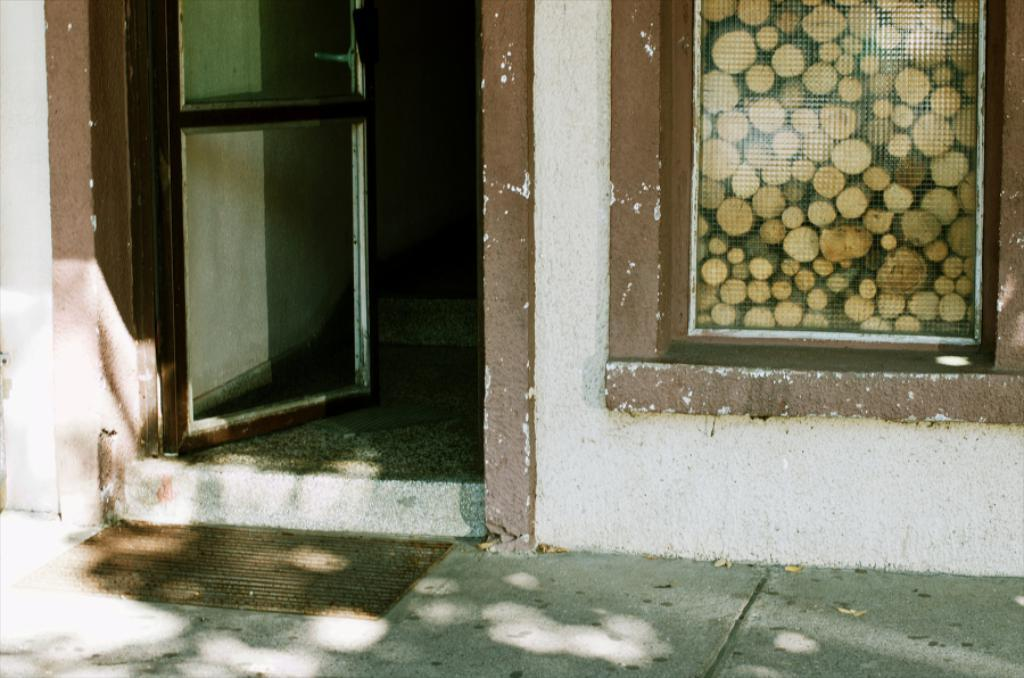What type of door is visible in the image? There is a glass door in the image. Where is the window located in the image? There is a glass window on the right side of the image. What can be found on the floor in the image? There is a doormat on the floor in the image. What type of wave can be seen crashing against the glass door in the image? There is no wave present in the image; it features a glass door, window, and doormat. What type of test is being conducted in the image? There is no test being conducted in the image; it features a glass door, window, and doormat. 